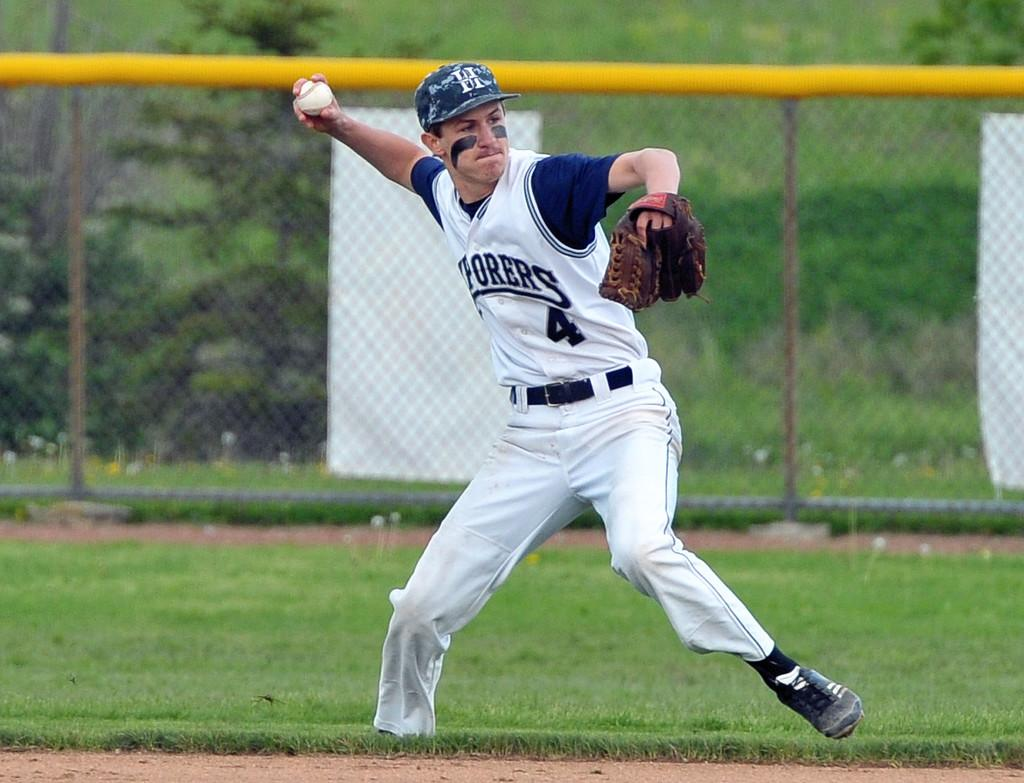<image>
Give a short and clear explanation of the subsequent image. a man pitching a ball in a jersey with letters Orers on it 